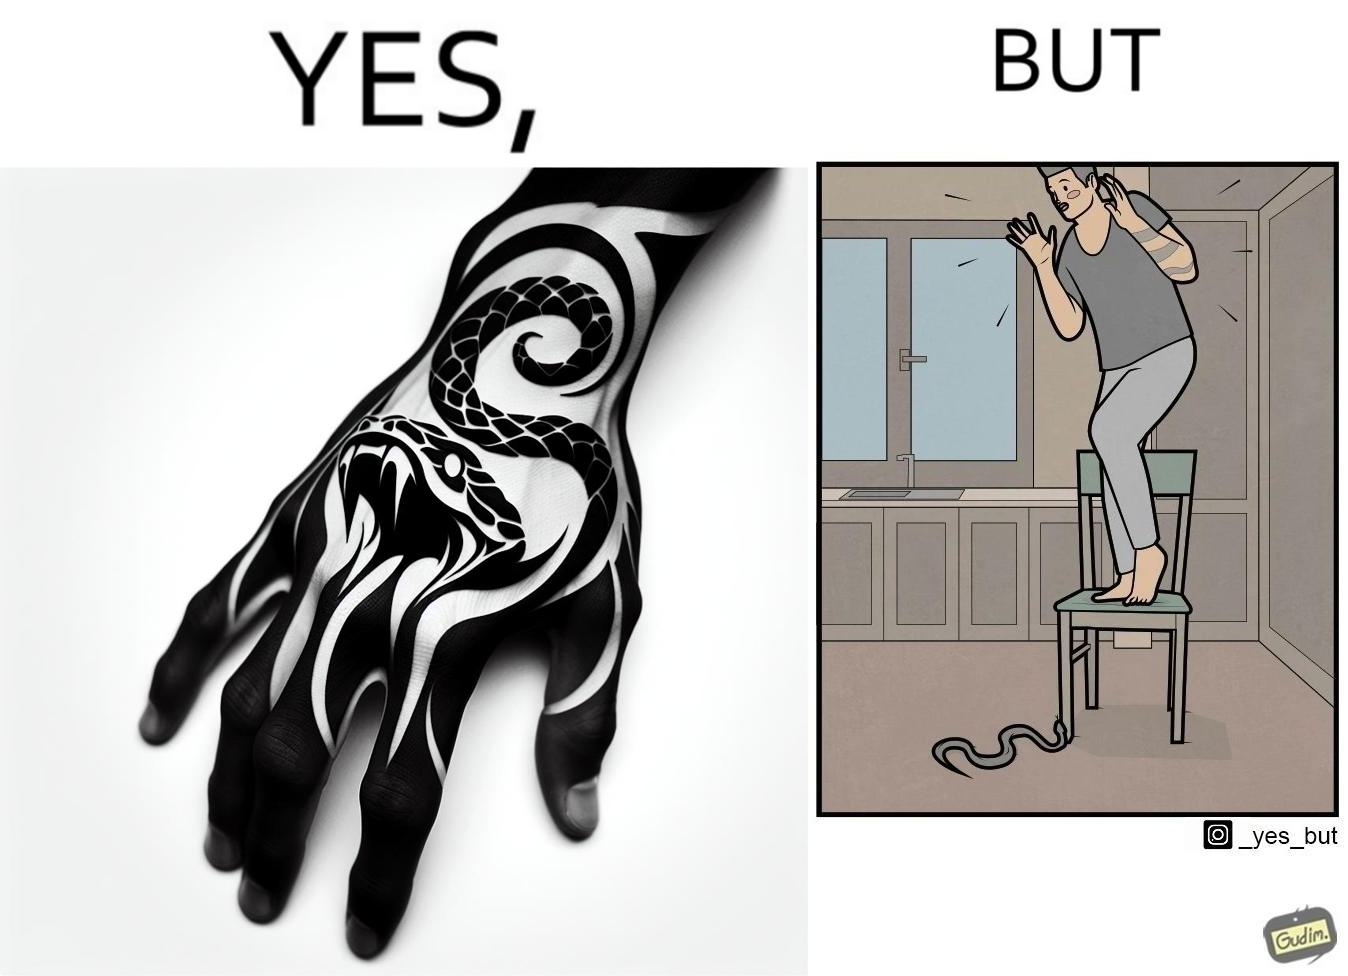Why is this image considered satirical? The image is ironic, because in the first image the tattoo of a snake on someone's hand may give us a hint about how powerful or brave the person can be who is having this tattoo but in the second image the person with same tattoo is seen frightened due to a snake in his house 